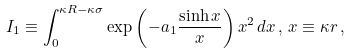<formula> <loc_0><loc_0><loc_500><loc_500>I _ { 1 } \equiv \int ^ { \kappa R - \kappa \sigma } _ { 0 } \exp { \left ( - a _ { 1 } \frac { \sinh { x } } { x } \right ) } \, x ^ { 2 } \, d x \, , \, x \equiv \kappa r \, ,</formula> 